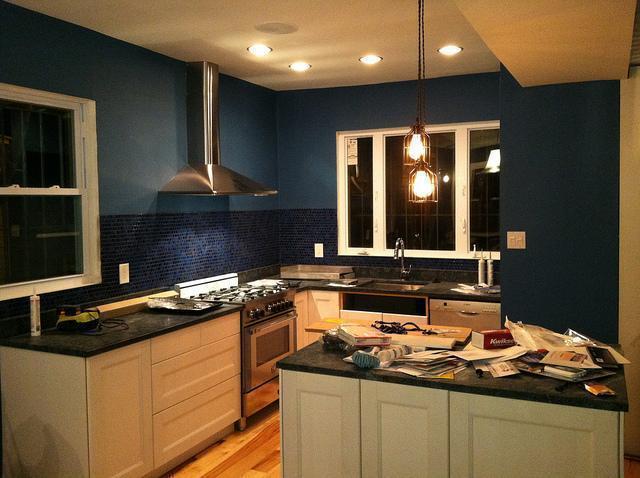What kind of backsplash has been attached to the wall?
From the following four choices, select the correct answer to address the question.
Options: Natural stone, metal, stainless steel, glass. Glass. 